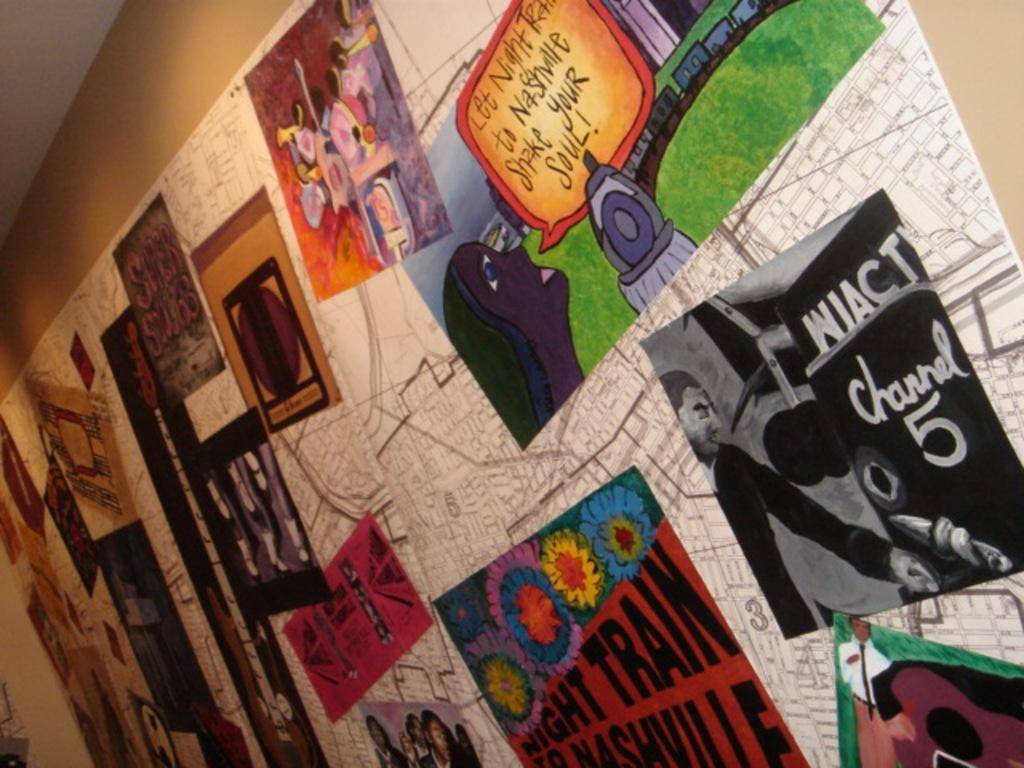What is present on the wall in the image? The wall has posters on it. What can be found on the posters? The posters contain text and images. Where is the roof located in the image? The roof is in the top left of the image. What type of toothbrush is recommended by the posters in the image? There is no toothbrush mentioned or depicted in the image, as the posters contain text and images related to other topics. 